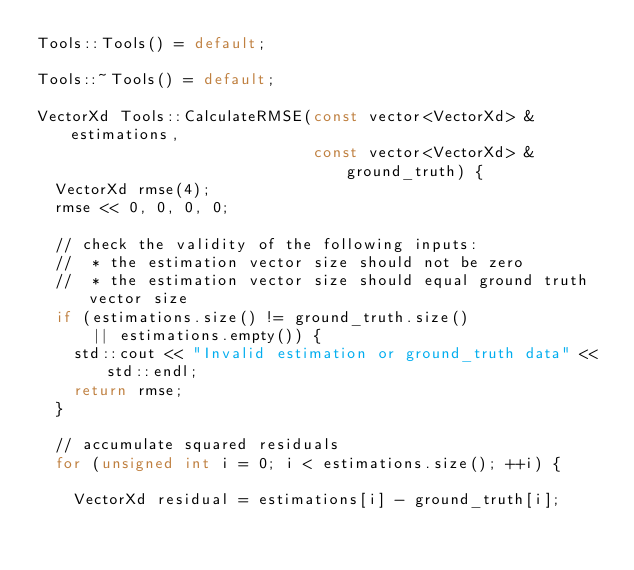<code> <loc_0><loc_0><loc_500><loc_500><_C++_>Tools::Tools() = default;

Tools::~Tools() = default;

VectorXd Tools::CalculateRMSE(const vector<VectorXd> &estimations,
                              const vector<VectorXd> &ground_truth) {
  VectorXd rmse(4);
  rmse << 0, 0, 0, 0;

  // check the validity of the following inputs:
  //  * the estimation vector size should not be zero
  //  * the estimation vector size should equal ground truth vector size
  if (estimations.size() != ground_truth.size()
      || estimations.empty()) {
    std::cout << "Invalid estimation or ground_truth data" << std::endl;
    return rmse;
  }

  // accumulate squared residuals
  for (unsigned int i = 0; i < estimations.size(); ++i) {

    VectorXd residual = estimations[i] - ground_truth[i];
</code> 